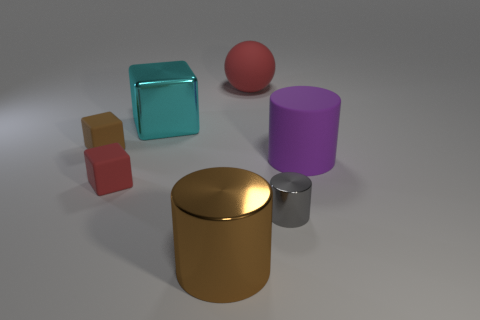There is a big shiny object in front of the gray cylinder; what color is it?
Your answer should be compact. Brown. Are there any large matte things that have the same shape as the small red matte thing?
Your answer should be compact. No. How many cyan objects are small rubber cubes or matte spheres?
Provide a short and direct response. 0. Is there a shiny cylinder that has the same size as the gray object?
Your answer should be very brief. No. How many large shiny objects are there?
Keep it short and to the point. 2. How many small things are either purple objects or yellow things?
Your answer should be very brief. 0. There is a small rubber block that is right of the small matte cube that is behind the red matte object that is to the left of the big brown cylinder; what is its color?
Your answer should be very brief. Red. How many other objects are there of the same color as the large matte sphere?
Keep it short and to the point. 1. What number of matte objects are purple cylinders or big things?
Your response must be concise. 2. Does the large shiny thing that is in front of the brown rubber object have the same color as the matte cube that is behind the large matte cylinder?
Ensure brevity in your answer.  Yes. 